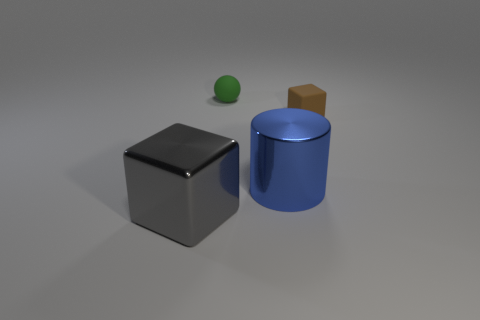Are there any objects in the image that tell us about the scale or size? The objects themselves provide some clues about scale, though without a reference object of a known size, it's hard to be sure. Typically, a cylinder, cube, and sphere are common shapes used in size comparison exercises. Assuming the cube is akin to a standard dice, which is about 16mm on each side, the other objects would be relatively larger, with the cylinder being the largest object in the scene. However, if no standardized object for scale is present, the exact dimensions remain uncertain. 